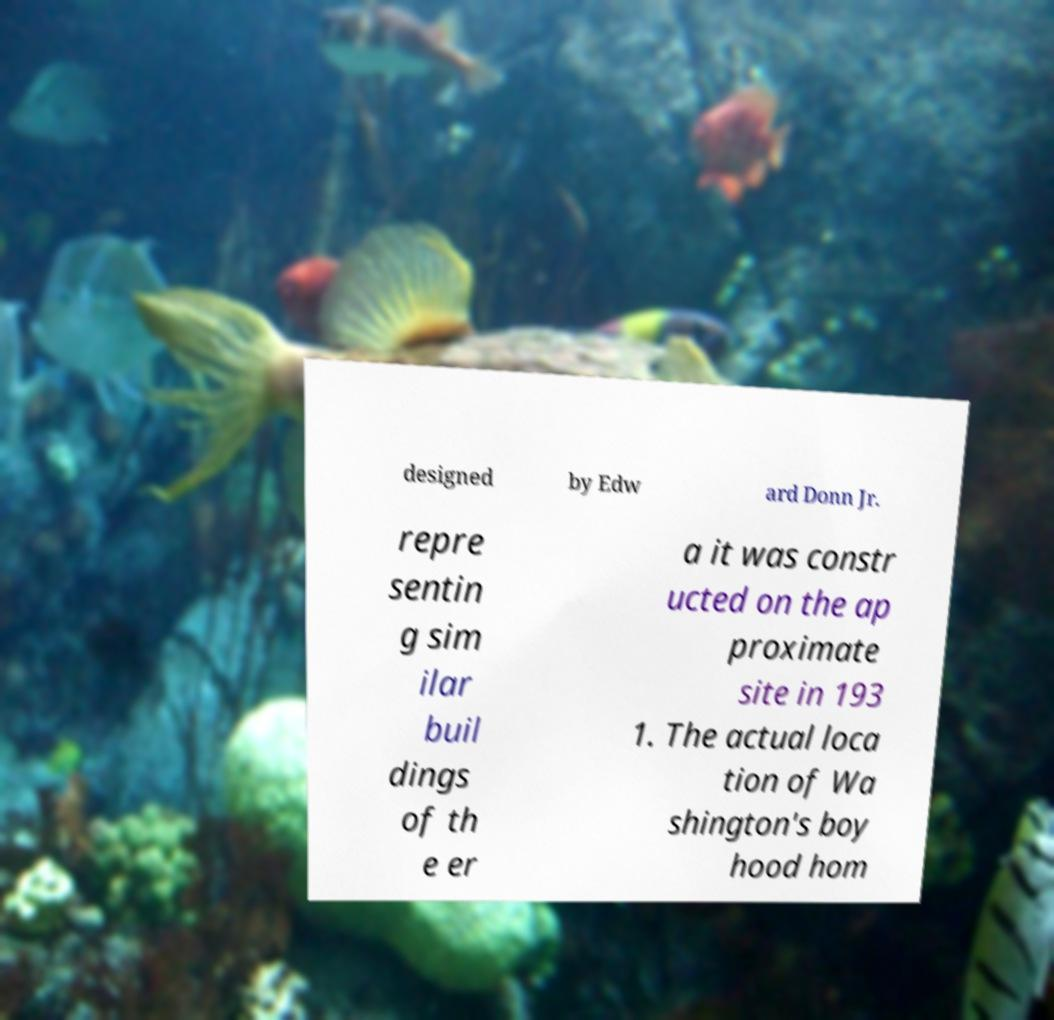Can you accurately transcribe the text from the provided image for me? designed by Edw ard Donn Jr. repre sentin g sim ilar buil dings of th e er a it was constr ucted on the ap proximate site in 193 1. The actual loca tion of Wa shington's boy hood hom 